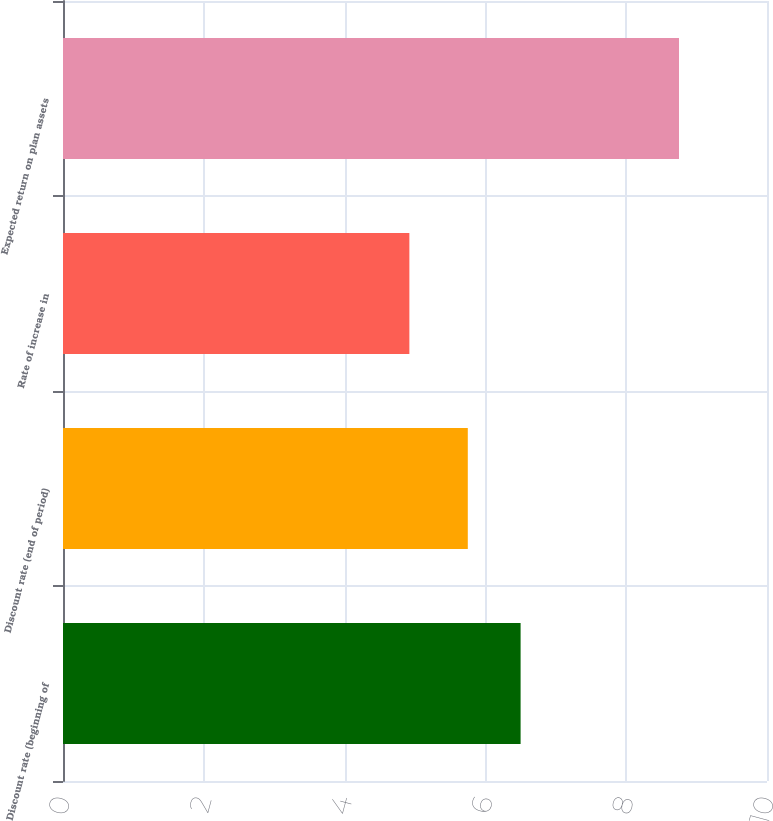<chart> <loc_0><loc_0><loc_500><loc_500><bar_chart><fcel>Discount rate (beginning of<fcel>Discount rate (end of period)<fcel>Rate of increase in<fcel>Expected return on plan assets<nl><fcel>6.5<fcel>5.75<fcel>4.92<fcel>8.75<nl></chart> 